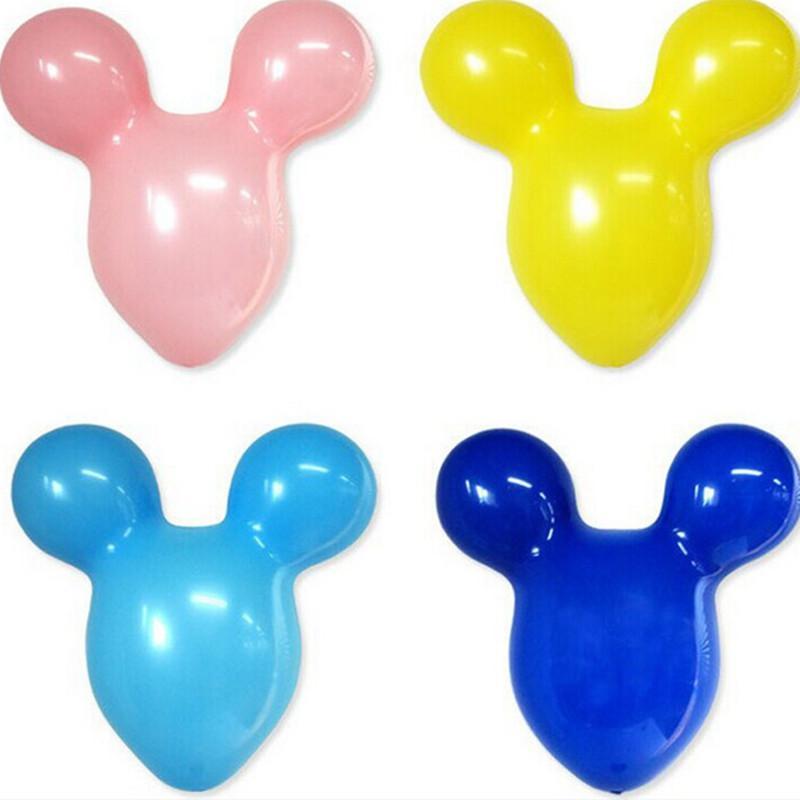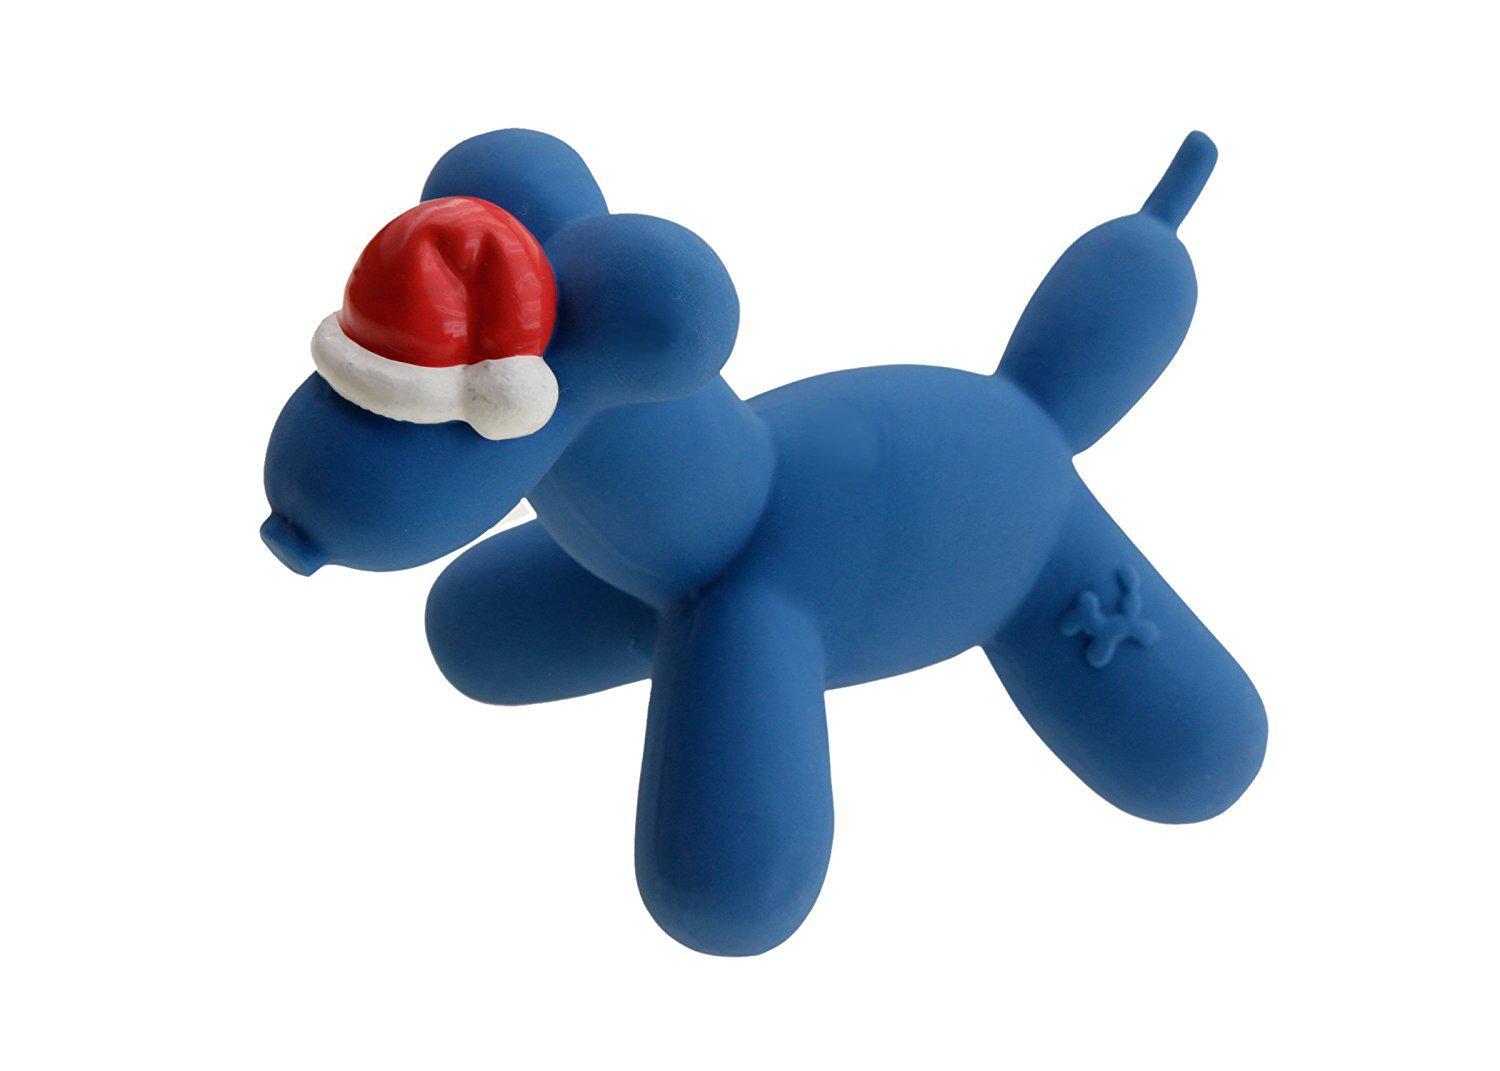The first image is the image on the left, the second image is the image on the right. Assess this claim about the two images: "there is one blue balloon in a shape of a dog facing left". Correct or not? Answer yes or no. Yes. 